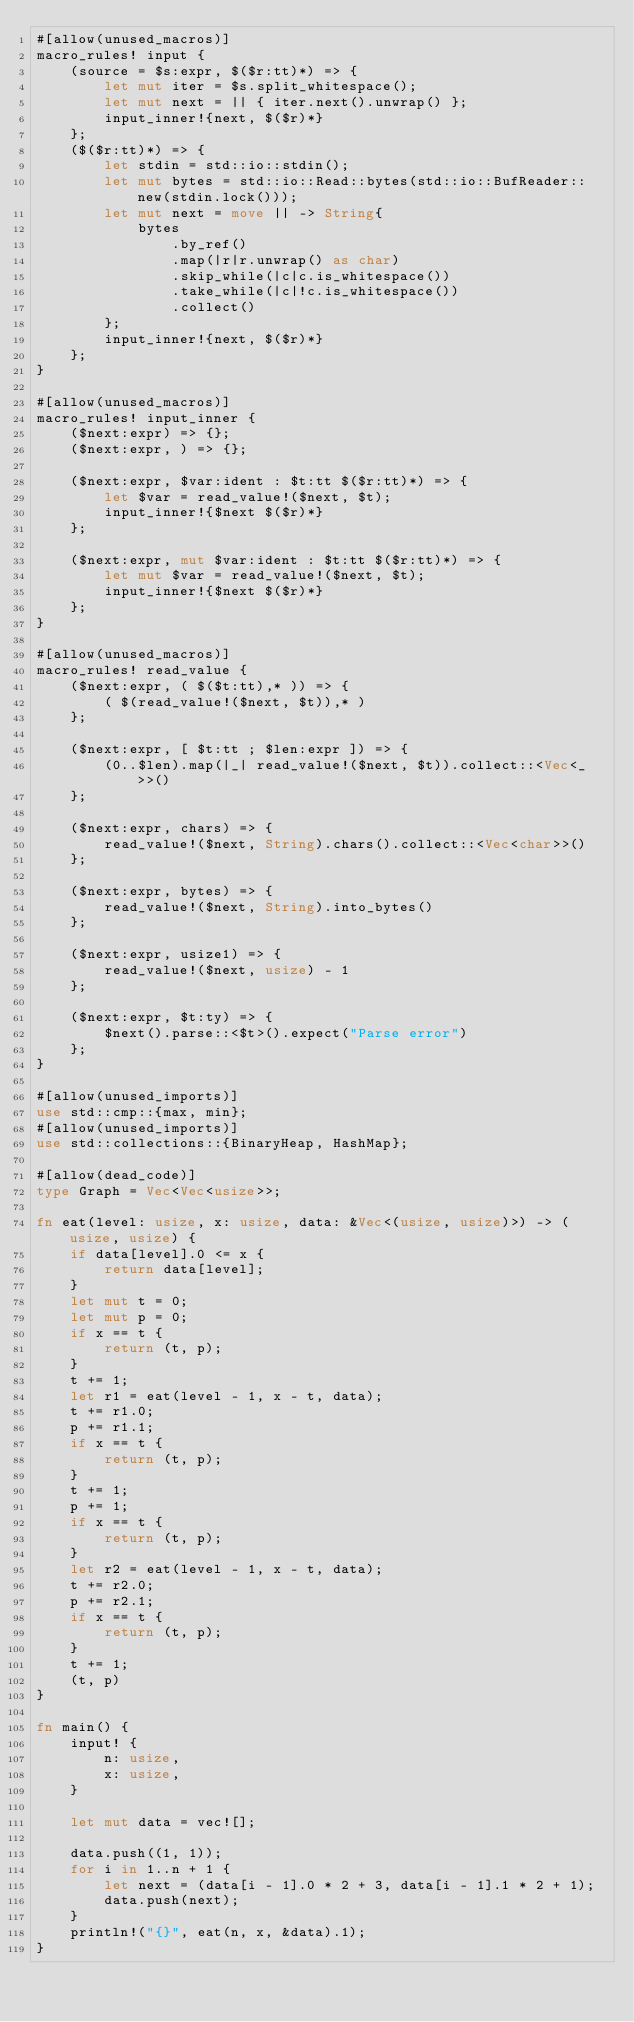Convert code to text. <code><loc_0><loc_0><loc_500><loc_500><_Rust_>#[allow(unused_macros)]
macro_rules! input {
    (source = $s:expr, $($r:tt)*) => {
        let mut iter = $s.split_whitespace();
        let mut next = || { iter.next().unwrap() };
        input_inner!{next, $($r)*}
    };
    ($($r:tt)*) => {
        let stdin = std::io::stdin();
        let mut bytes = std::io::Read::bytes(std::io::BufReader::new(stdin.lock()));
        let mut next = move || -> String{
            bytes
                .by_ref()
                .map(|r|r.unwrap() as char)
                .skip_while(|c|c.is_whitespace())
                .take_while(|c|!c.is_whitespace())
                .collect()
        };
        input_inner!{next, $($r)*}
    };
}

#[allow(unused_macros)]
macro_rules! input_inner {
    ($next:expr) => {};
    ($next:expr, ) => {};

    ($next:expr, $var:ident : $t:tt $($r:tt)*) => {
        let $var = read_value!($next, $t);
        input_inner!{$next $($r)*}
    };

    ($next:expr, mut $var:ident : $t:tt $($r:tt)*) => {
        let mut $var = read_value!($next, $t);
        input_inner!{$next $($r)*}
    };
}

#[allow(unused_macros)]
macro_rules! read_value {
    ($next:expr, ( $($t:tt),* )) => {
        ( $(read_value!($next, $t)),* )
    };

    ($next:expr, [ $t:tt ; $len:expr ]) => {
        (0..$len).map(|_| read_value!($next, $t)).collect::<Vec<_>>()
    };

    ($next:expr, chars) => {
        read_value!($next, String).chars().collect::<Vec<char>>()
    };

    ($next:expr, bytes) => {
        read_value!($next, String).into_bytes()
    };

    ($next:expr, usize1) => {
        read_value!($next, usize) - 1
    };

    ($next:expr, $t:ty) => {
        $next().parse::<$t>().expect("Parse error")
    };
}

#[allow(unused_imports)]
use std::cmp::{max, min};
#[allow(unused_imports)]
use std::collections::{BinaryHeap, HashMap};

#[allow(dead_code)]
type Graph = Vec<Vec<usize>>;

fn eat(level: usize, x: usize, data: &Vec<(usize, usize)>) -> (usize, usize) {
    if data[level].0 <= x {
        return data[level];
    }
    let mut t = 0;
    let mut p = 0;
    if x == t {
        return (t, p);
    }
    t += 1;
    let r1 = eat(level - 1, x - t, data);
    t += r1.0;
    p += r1.1;
    if x == t {
        return (t, p);
    }
    t += 1;
    p += 1;
    if x == t {
        return (t, p);
    }
    let r2 = eat(level - 1, x - t, data);
    t += r2.0;
    p += r2.1;
    if x == t {
        return (t, p);
    }
    t += 1;
    (t, p)
}

fn main() {
    input! {
        n: usize,
        x: usize,
    }

    let mut data = vec![];

    data.push((1, 1));
    for i in 1..n + 1 {
        let next = (data[i - 1].0 * 2 + 3, data[i - 1].1 * 2 + 1);
        data.push(next);
    }
    println!("{}", eat(n, x, &data).1);
}
</code> 